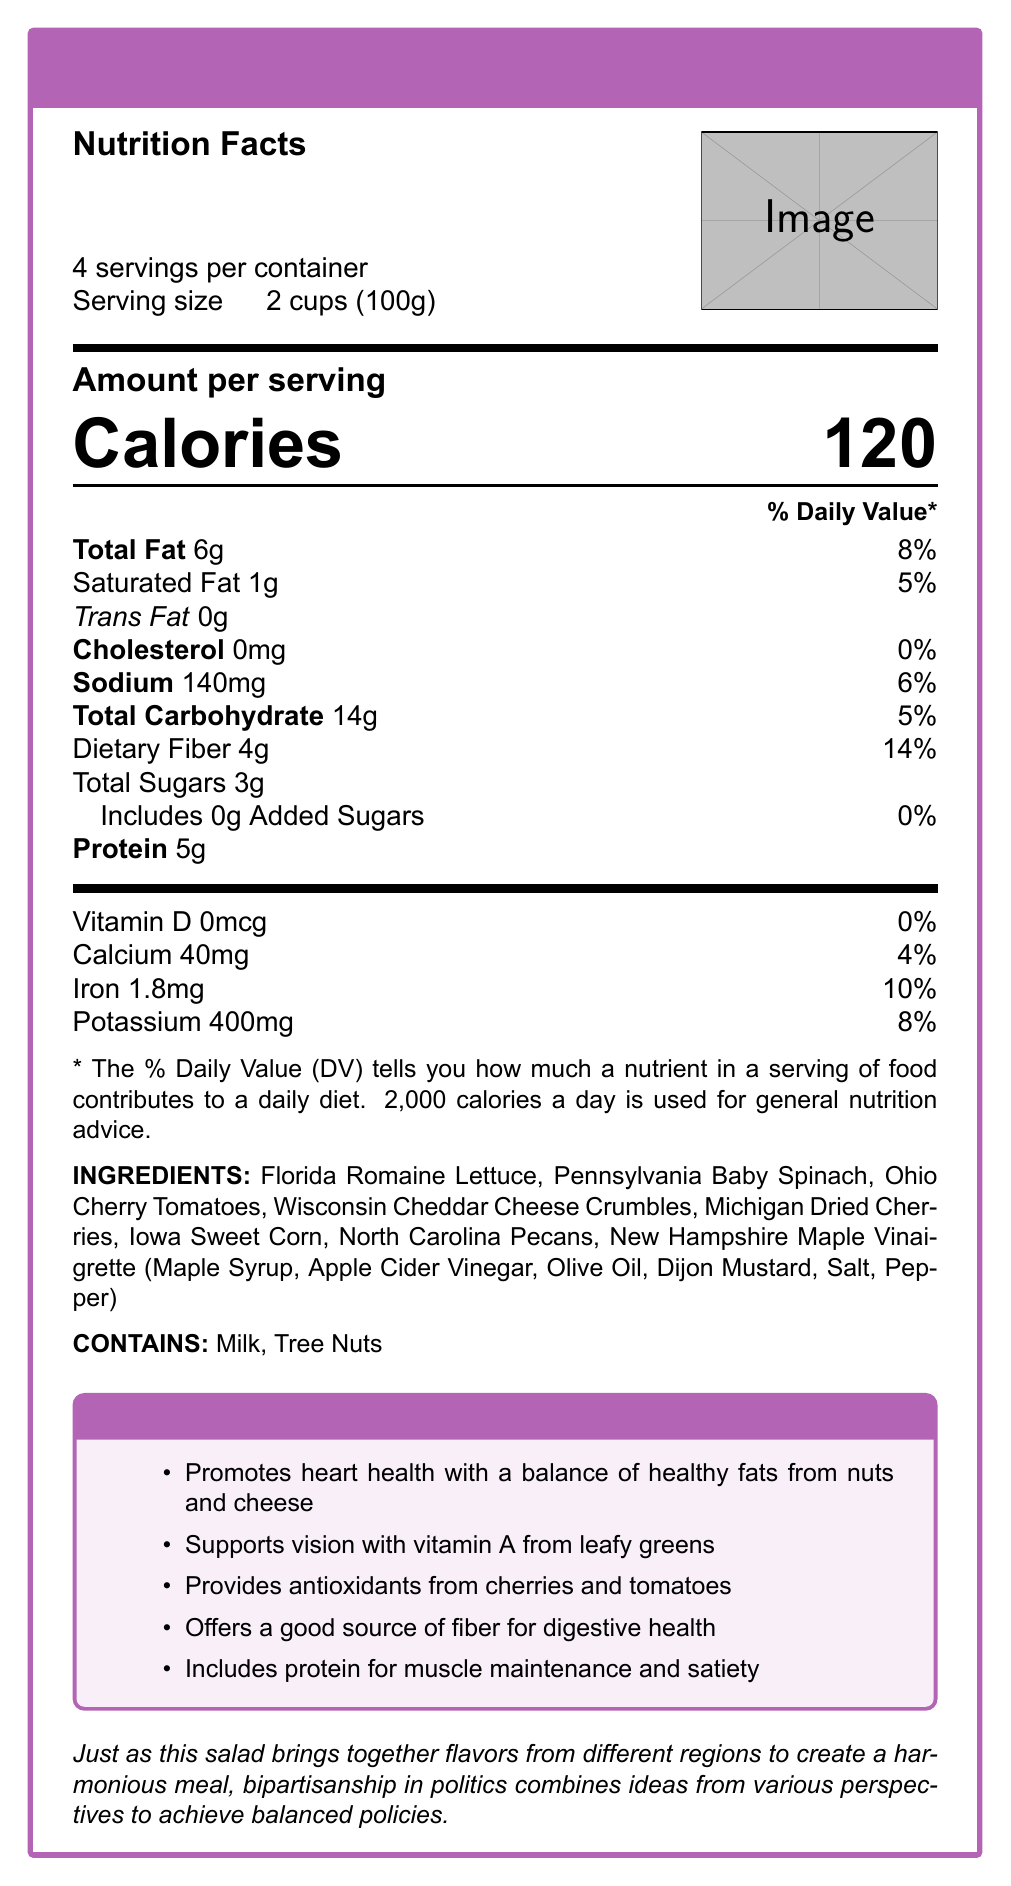what is the serving size? The document specifies that the serving size is 2 cups, which is equivalent to 100 grams.
Answer: 2 cups (100g) how many servings are in one container? The document states that there are 4 servings per container.
Answer: 4 how many calories are in one serving of the Swing State Salad Mix? The document displays the calories per serving as 120.
Answer: 120 what is the total amount of fat per serving and its % daily value? The document lists the total fat content as 6 grams per serving, which is 8% of the daily value.
Answer: 6g, 8% what ingredients contribute to the salad mix? The document includes a specific list of ingredients from various states, all contributing to the salad mix.
Answer: Florida Romaine Lettuce, Pennsylvania Baby Spinach, Ohio Cherry Tomatoes, Wisconsin Cheddar Cheese Crumbles, Michigan Dried Cherries, Iowa Sweet Corn, North Carolina Pecans, New Hampshire Maple Vinaigrette what allergens are present in the Swing State Salad Mix? The document indicates that the Swing State Salad Mix contains milk and tree nuts.
Answer: Milk, Tree Nuts how much protein is in one serving of the Swing State Salad Mix? The document notes that each serving contains 5 grams of protein.
Answer: 5g which state is not represented in the ingredient list? A. Florida B. Texas C. Michigan D. Iowa Florida, Michigan, and Iowa are listed as ingredient sources, but Texas is not mentioned.
Answer: B what is the % daily value of dietary fiber per serving? A. 4% B. 14% C. 10% D. 8% The document states that the dietary fiber in one serving amounts to 14% of the daily value.
Answer: B does the Swing State Salad Mix contain cholesterol? The document shows that the cholesterol content is 0mg, indicating it does not contain cholesterol.
Answer: No summarize the main idea of the document. The document contains detailed nutritional information, ingredients list, allergen warnings, and emphasizes the importance of balanced nutrition and politics by sourcing ingredients from various states. It also notes the health benefits and regional representation.
Answer: The Swing State Salad Mix emphasizes a balanced nutritional profile with ingredients sourced from various politically significant states to highlight the importance of diverse perspectives in both nutrition and politics. It provides detailed nutritional information, ingredients, allergen warnings, and highlights the bipartisan benefits of the mix. what are the bipartisan benefits of the Swing State Salad Mix listed in the document? The document lists several bipartisan benefits, including promoting heart health, supporting vision, providing antioxidants, offering fiber for digestive health, and including protein for muscle maintenance.
Answer: Promotes heart health, supports vision, provides antioxidants, offers fiber for digestive health, includes protein for muscle maintenance how much calcium is in one serving and what % daily value does it represent? The document states that one serving contains 40mg of calcium, which is 4% of the daily value.
Answer: 40mg, 4% what percentage of daily value does the iron content represent? The document mentions that the iron content in one serving is 1.8mg, which is 10% of the daily value.
Answer: 10% where can you find the image referenced in the document? The document includes a placeholder for an image ("example-image") but doesn't provide a visible or specific image.
Answer: Cannot be determined how is the importance of regional representation shown in the Swing State Salad Mix? The document features ingredients sourced from multiple politically significant states to highlight the importance of considering diverse perspectives in both nutrition and politics.
Answer: By including ingredients from various politically significant states such as Florida, Pennsylvania, Ohio, Wisconsin, Michigan, Iowa, North Carolina, and New Hampshire 